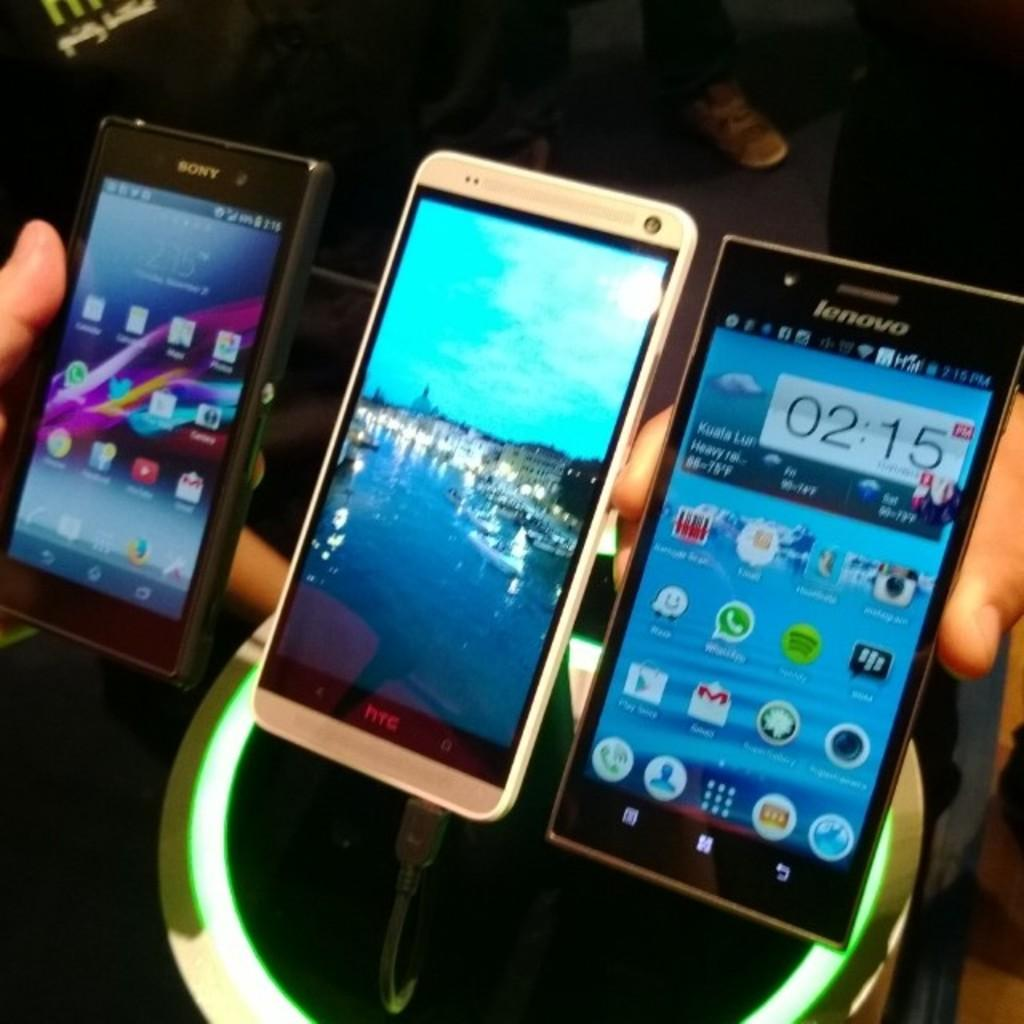Provide a one-sentence caption for the provided image. Three mobile phones lined up in hands, with the closest one being lenovo and the middle htc charging. 